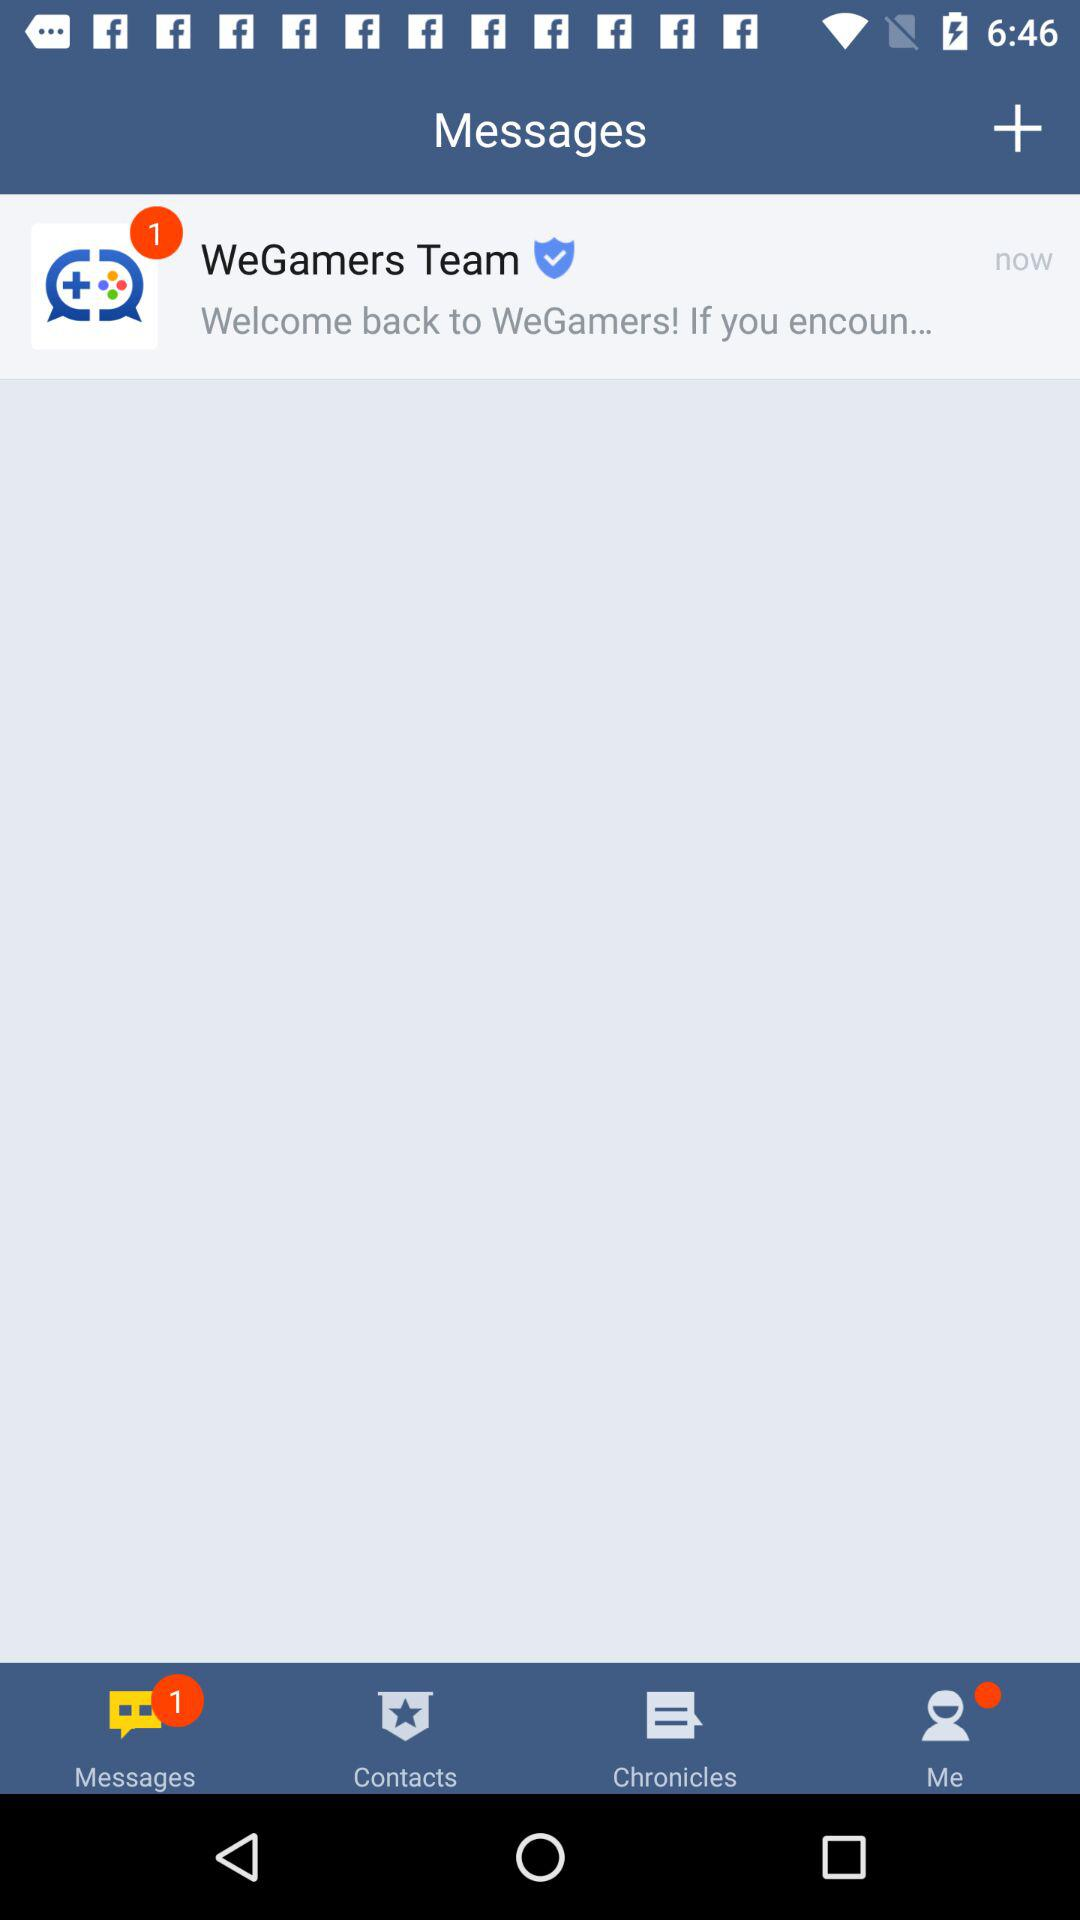How many unread messages are there? There is 1 unread message. 